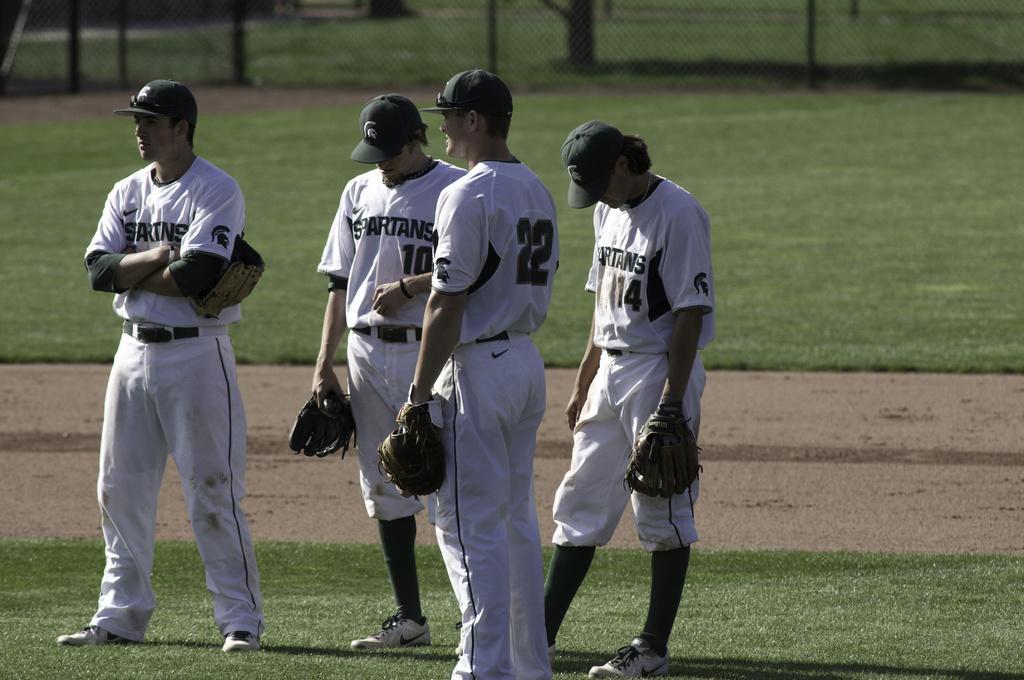How would you summarize this image in a sentence or two? In this image in the front there are persons standing and holding gloves in their hands. In the background there is grass on the ground, there is a fence and behind the fence there are poles and there is a tree trunk visible. 